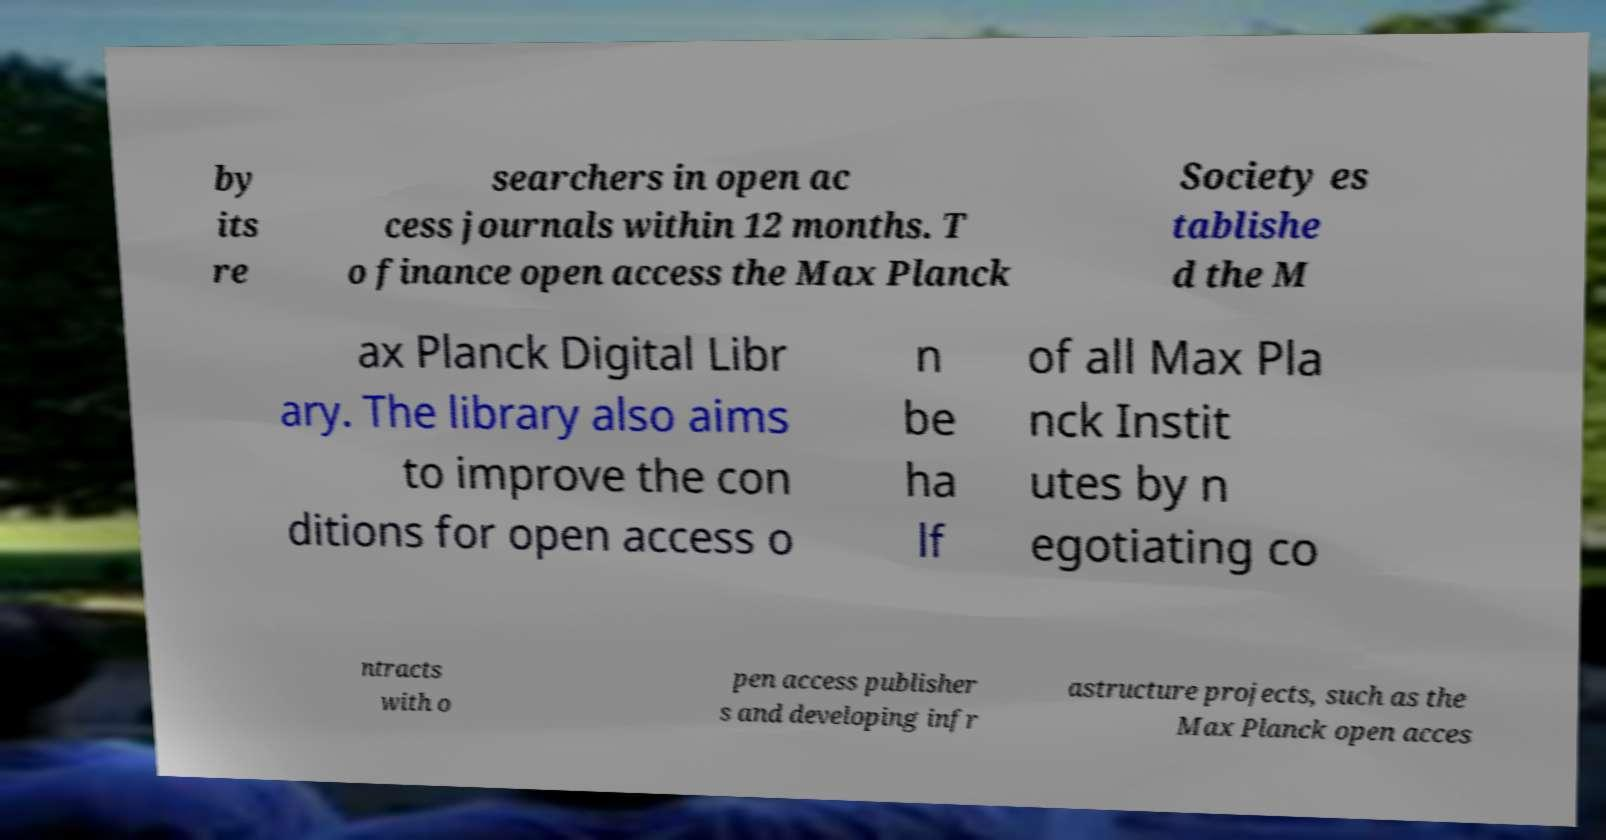For documentation purposes, I need the text within this image transcribed. Could you provide that? by its re searchers in open ac cess journals within 12 months. T o finance open access the Max Planck Society es tablishe d the M ax Planck Digital Libr ary. The library also aims to improve the con ditions for open access o n be ha lf of all Max Pla nck Instit utes by n egotiating co ntracts with o pen access publisher s and developing infr astructure projects, such as the Max Planck open acces 